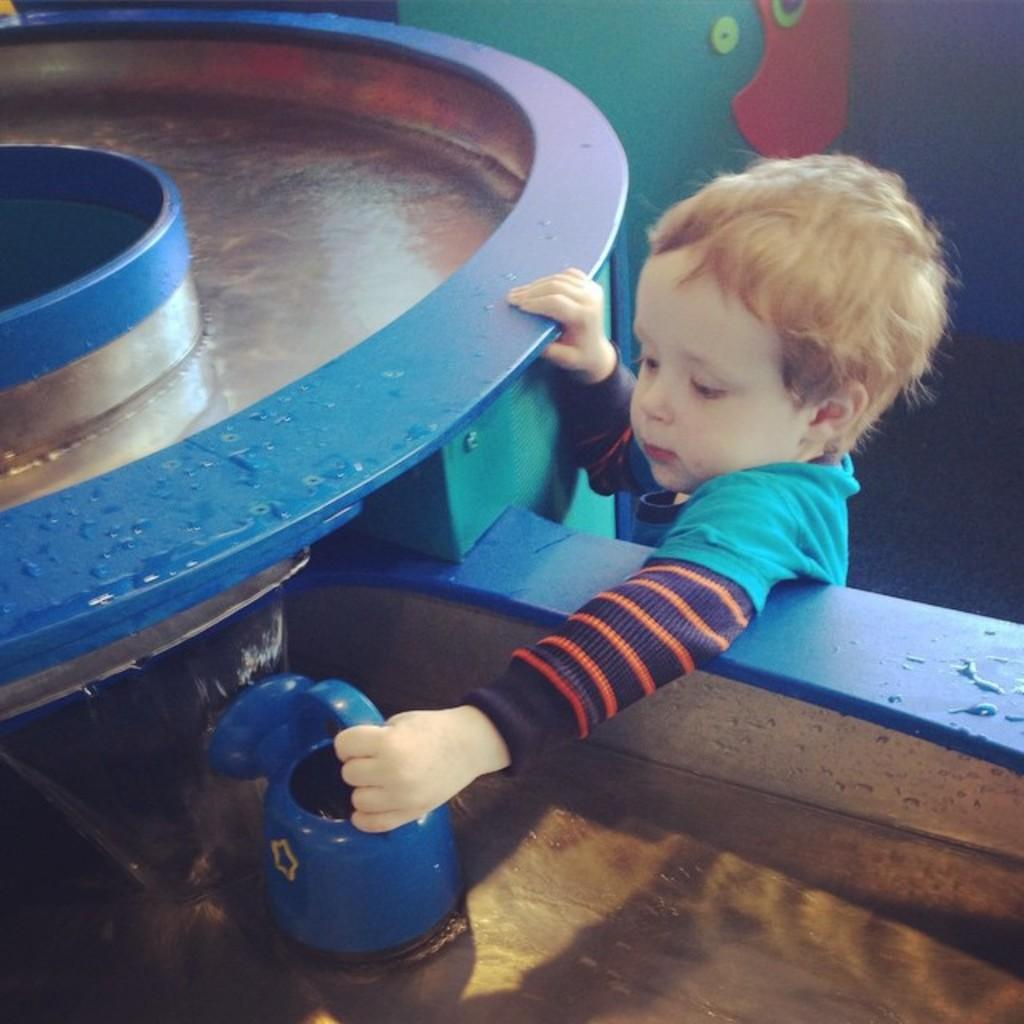Who is the main subject in the image? There is a child in the image. What is the child holding in the image? The child is holding a blue object. Can you describe the blue object in the image? There is a blue round object in the image. What can be seen in the background of the image? There is a wall in the background of the image. What is the child's opinion on the word "hobbies" in the image? There is no reference to the word "hobbies" or any opinions in the image, as it features a child holding a blue round object with a wall in the background. 